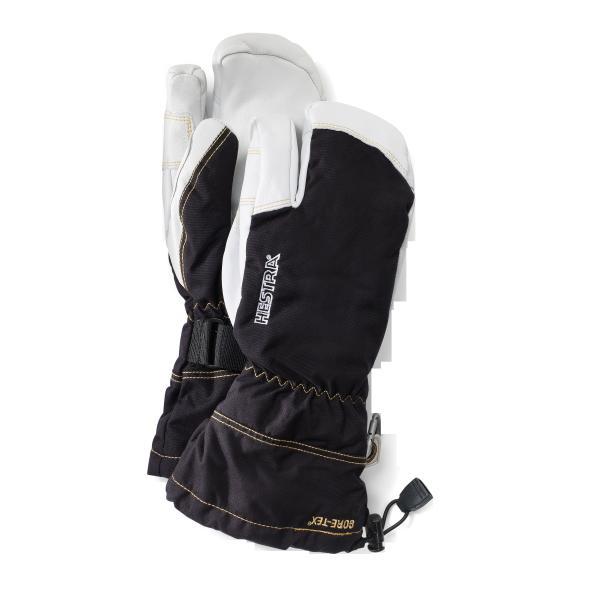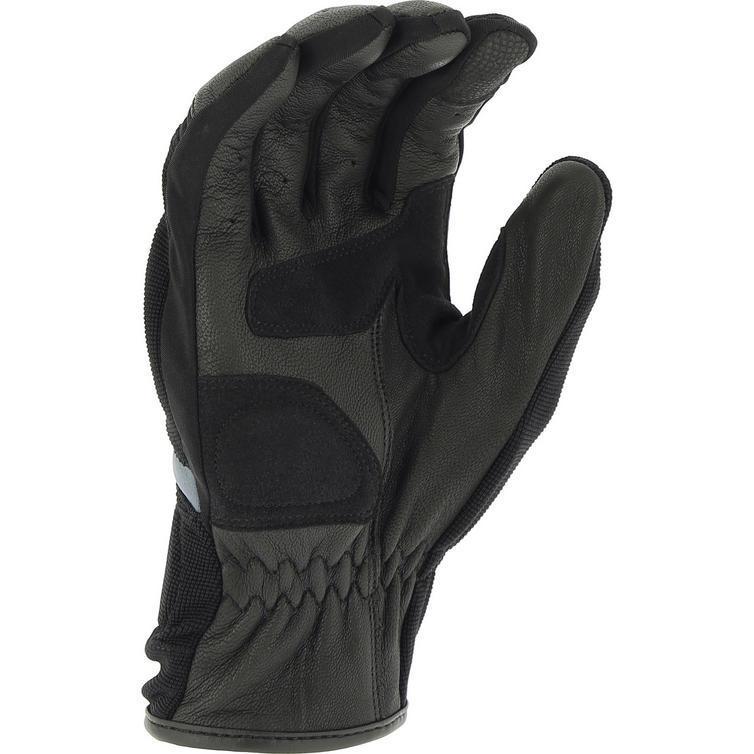The first image is the image on the left, the second image is the image on the right. Assess this claim about the two images: "One image contains a pair of white and dark two-toned gloves, and the other contains a single glove.". Correct or not? Answer yes or no. Yes. The first image is the image on the left, the second image is the image on the right. For the images displayed, is the sentence "None of the gloves or mittens make a pair." factually correct? Answer yes or no. No. 